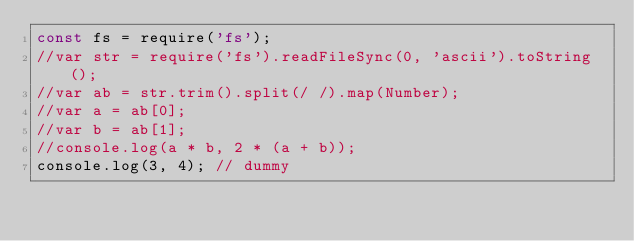<code> <loc_0><loc_0><loc_500><loc_500><_JavaScript_>const fs = require('fs');
//var str = require('fs').readFileSync(0, 'ascii').toString();
//var ab = str.trim().split(/ /).map(Number);
//var a = ab[0];
//var b = ab[1];
//console.log(a * b, 2 * (a + b));
console.log(3, 4); // dummy</code> 